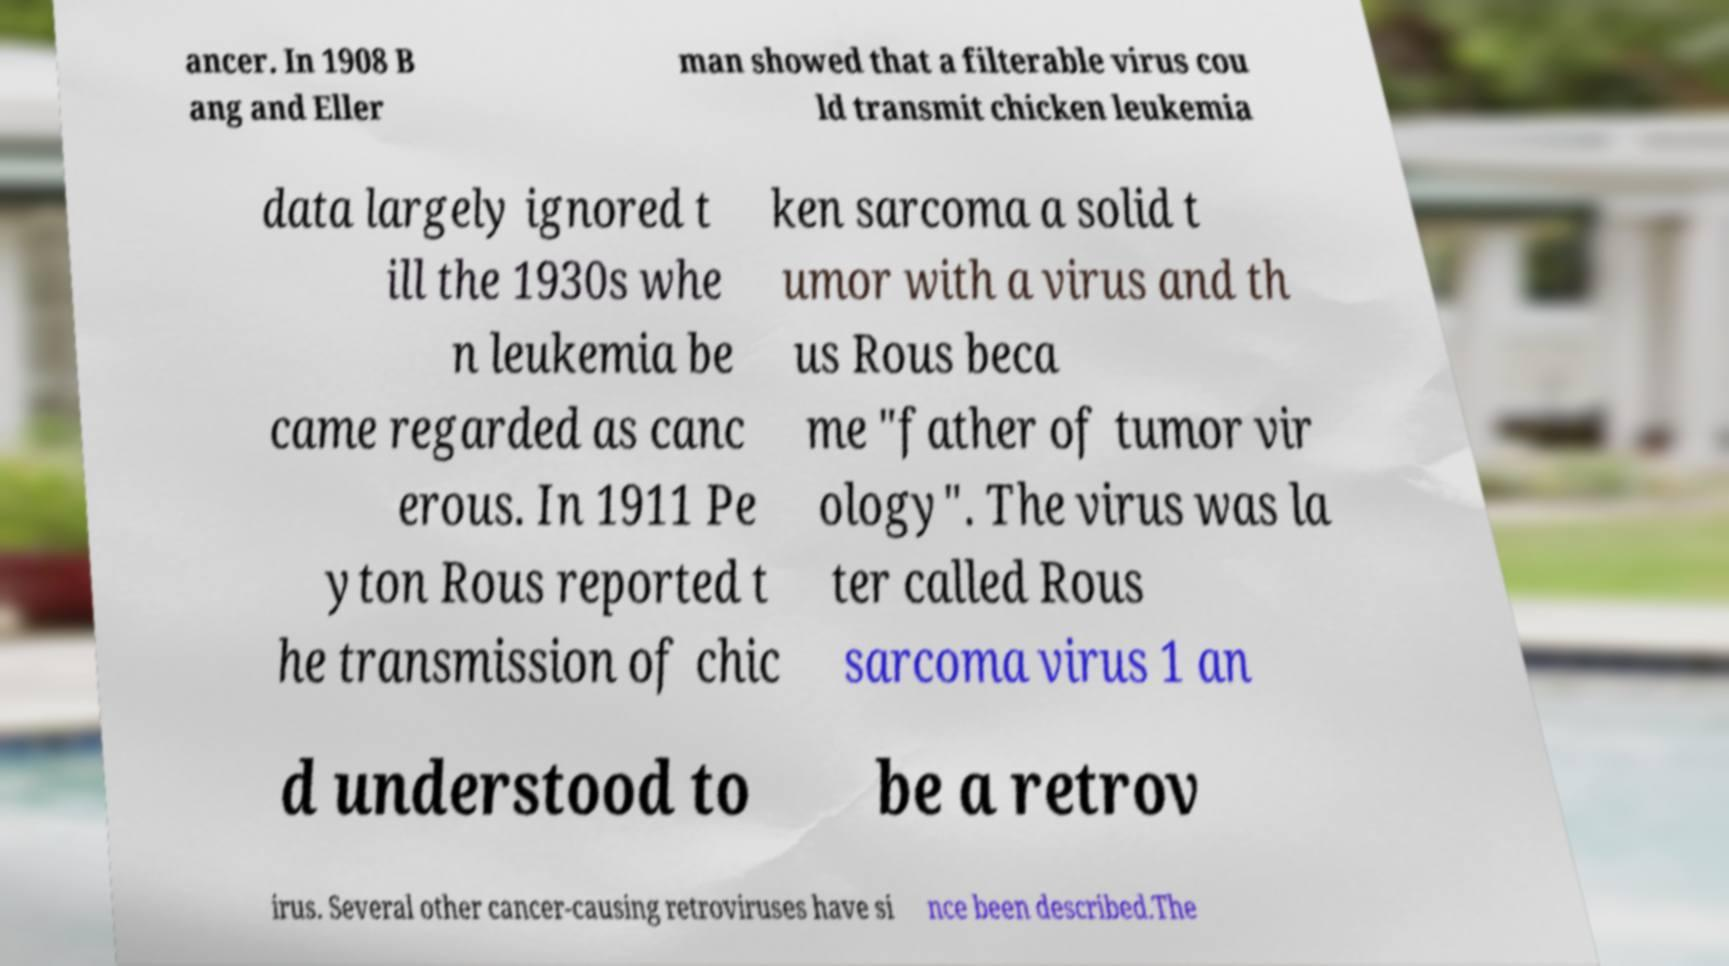Can you accurately transcribe the text from the provided image for me? ancer. In 1908 B ang and Eller man showed that a filterable virus cou ld transmit chicken leukemia data largely ignored t ill the 1930s whe n leukemia be came regarded as canc erous. In 1911 Pe yton Rous reported t he transmission of chic ken sarcoma a solid t umor with a virus and th us Rous beca me "father of tumor vir ology". The virus was la ter called Rous sarcoma virus 1 an d understood to be a retrov irus. Several other cancer-causing retroviruses have si nce been described.The 